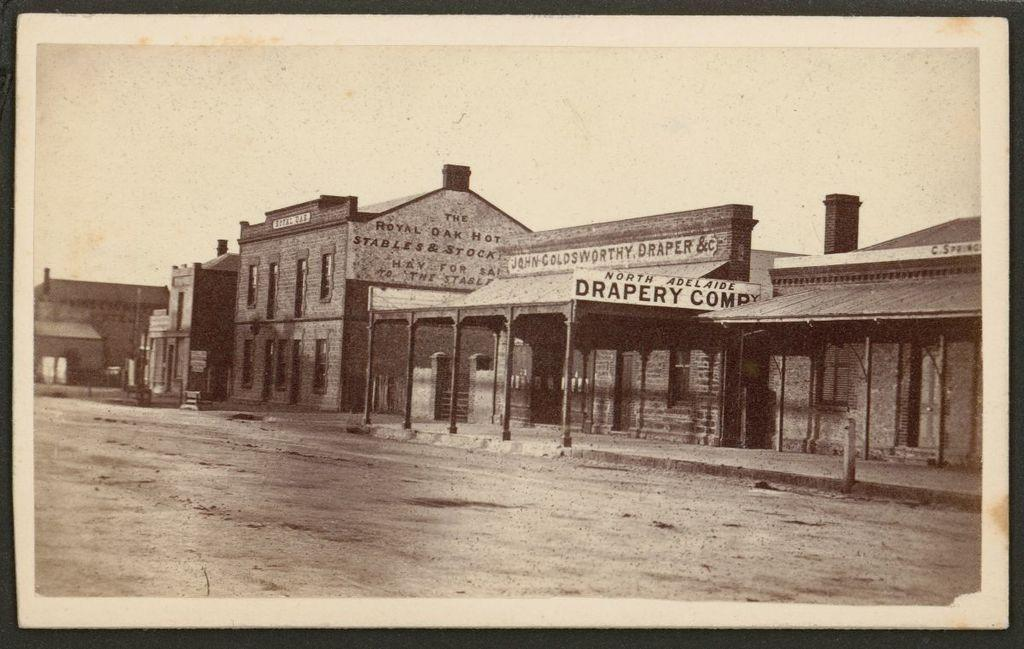What type of structures can be seen in the image? There are houses in the image. What else is present in the image besides the houses? There are hoardings in the image. How is the image presented in terms of color? The image is a black and white photography. Can you tell me what time it is in the image? The image does not provide any information about the time, as it is a black and white photography. Is there a crown visible on any of the houses in the image? There is no crown present on any of the houses in the image. 